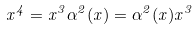<formula> <loc_0><loc_0><loc_500><loc_500>x ^ { 4 } = x ^ { 3 } \alpha ^ { 2 } ( x ) = \alpha ^ { 2 } ( x ) x ^ { 3 }</formula> 